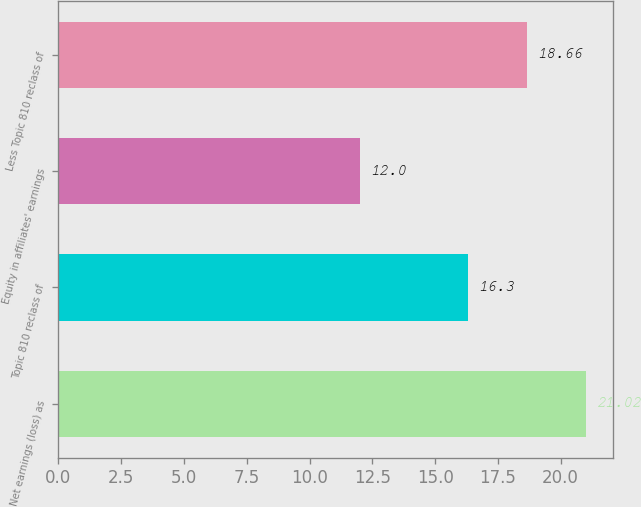Convert chart. <chart><loc_0><loc_0><loc_500><loc_500><bar_chart><fcel>Net earnings (loss) as<fcel>Topic 810 reclass of<fcel>Equity in affiliates' earnings<fcel>Less Topic 810 reclass of<nl><fcel>21.02<fcel>16.3<fcel>12<fcel>18.66<nl></chart> 